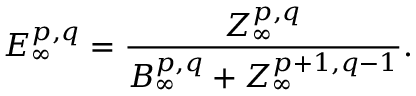<formula> <loc_0><loc_0><loc_500><loc_500>E _ { \infty } ^ { p , q } = { \frac { Z _ { \infty } ^ { p , q } } { B _ { \infty } ^ { p , q } + Z _ { \infty } ^ { p + 1 , q - 1 } } } .</formula> 